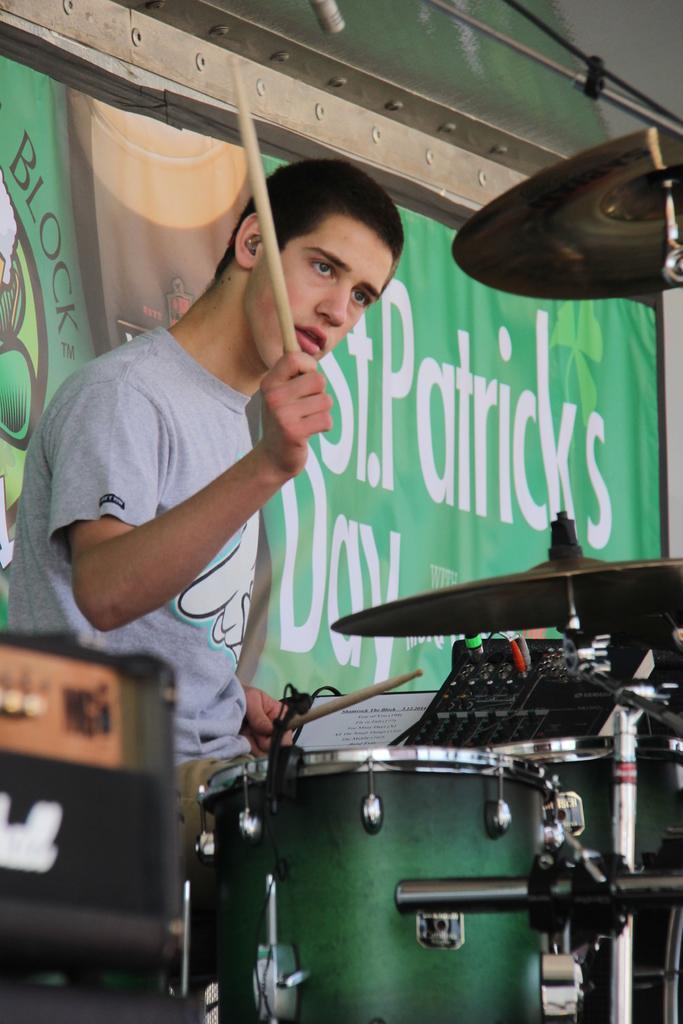Describe this image in one or two sentences. In this image I can see a man wearing t-shirt and playing the drums. In the background there is a banner. The man is holding sticks in his hands. 